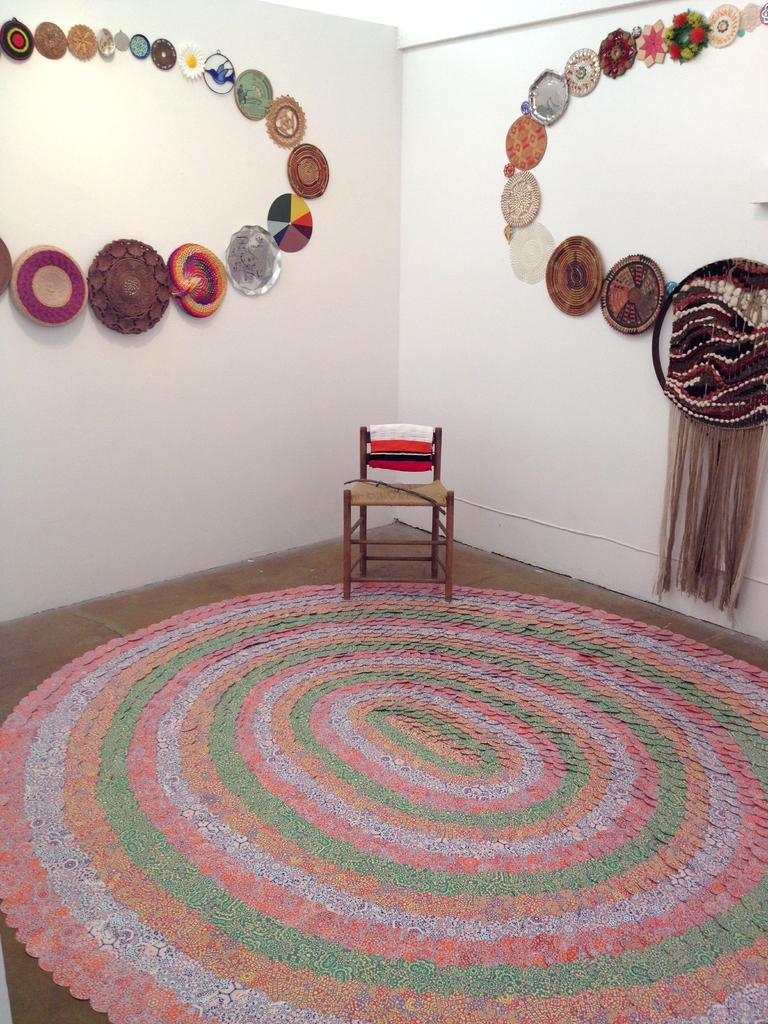Describe this image in one or two sentences. Here in this picture on the floor we can see a carpet present and in the middle we can also see a chair present and on the walls we can see some things used with which the wall is decorated. 